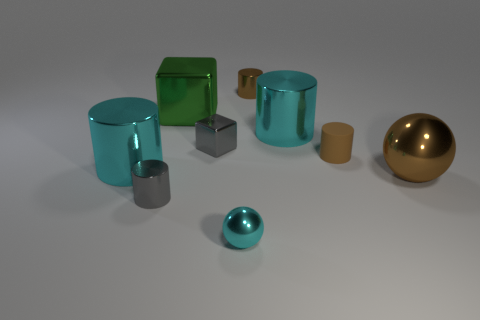What materials seem to be present in the objects displayed in the image? The objects in the image appear to be rendered with materials that simulate glass, metal, and a glossy, plastic-like finish. The transparent cyan objects, for example, have properties akin to glass, showing reflections and allowing light to pass through them. The golden sphere and the gray cylinders have a metallic sheen indicative of a metal material, and the green cube and tan cylinders exhibit a solid, non-reflective surface reminiscent of a matte, plastic finish. 